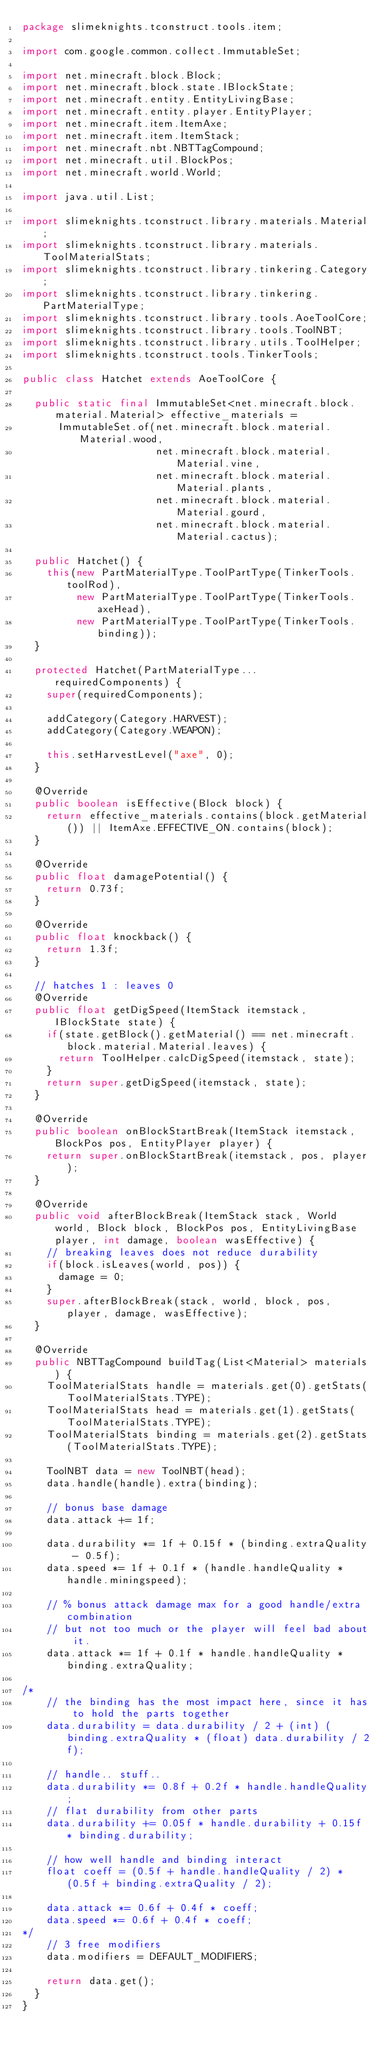<code> <loc_0><loc_0><loc_500><loc_500><_Java_>package slimeknights.tconstruct.tools.item;

import com.google.common.collect.ImmutableSet;

import net.minecraft.block.Block;
import net.minecraft.block.state.IBlockState;
import net.minecraft.entity.EntityLivingBase;
import net.minecraft.entity.player.EntityPlayer;
import net.minecraft.item.ItemAxe;
import net.minecraft.item.ItemStack;
import net.minecraft.nbt.NBTTagCompound;
import net.minecraft.util.BlockPos;
import net.minecraft.world.World;

import java.util.List;

import slimeknights.tconstruct.library.materials.Material;
import slimeknights.tconstruct.library.materials.ToolMaterialStats;
import slimeknights.tconstruct.library.tinkering.Category;
import slimeknights.tconstruct.library.tinkering.PartMaterialType;
import slimeknights.tconstruct.library.tools.AoeToolCore;
import slimeknights.tconstruct.library.tools.ToolNBT;
import slimeknights.tconstruct.library.utils.ToolHelper;
import slimeknights.tconstruct.tools.TinkerTools;

public class Hatchet extends AoeToolCore {

  public static final ImmutableSet<net.minecraft.block.material.Material> effective_materials =
      ImmutableSet.of(net.minecraft.block.material.Material.wood,
                      net.minecraft.block.material.Material.vine,
                      net.minecraft.block.material.Material.plants,
                      net.minecraft.block.material.Material.gourd,
                      net.minecraft.block.material.Material.cactus);

  public Hatchet() {
    this(new PartMaterialType.ToolPartType(TinkerTools.toolRod),
         new PartMaterialType.ToolPartType(TinkerTools.axeHead),
         new PartMaterialType.ToolPartType(TinkerTools.binding));
  }

  protected Hatchet(PartMaterialType... requiredComponents) {
    super(requiredComponents);

    addCategory(Category.HARVEST);
    addCategory(Category.WEAPON);

    this.setHarvestLevel("axe", 0);
  }

  @Override
  public boolean isEffective(Block block) {
    return effective_materials.contains(block.getMaterial()) || ItemAxe.EFFECTIVE_ON.contains(block);
  }

  @Override
  public float damagePotential() {
    return 0.73f;
  }

  @Override
  public float knockback() {
    return 1.3f;
  }

  // hatches 1 : leaves 0
  @Override
  public float getDigSpeed(ItemStack itemstack, IBlockState state) {
    if(state.getBlock().getMaterial() == net.minecraft.block.material.Material.leaves) {
      return ToolHelper.calcDigSpeed(itemstack, state);
    }
    return super.getDigSpeed(itemstack, state);
  }

  @Override
  public boolean onBlockStartBreak(ItemStack itemstack, BlockPos pos, EntityPlayer player) {
    return super.onBlockStartBreak(itemstack, pos, player);
  }

  @Override
  public void afterBlockBreak(ItemStack stack, World world, Block block, BlockPos pos, EntityLivingBase player, int damage, boolean wasEffective) {
    // breaking leaves does not reduce durability
    if(block.isLeaves(world, pos)) {
      damage = 0;
    }
    super.afterBlockBreak(stack, world, block, pos, player, damage, wasEffective);
  }

  @Override
  public NBTTagCompound buildTag(List<Material> materials) {
    ToolMaterialStats handle = materials.get(0).getStats(ToolMaterialStats.TYPE);
    ToolMaterialStats head = materials.get(1).getStats(ToolMaterialStats.TYPE);
    ToolMaterialStats binding = materials.get(2).getStats(ToolMaterialStats.TYPE);

    ToolNBT data = new ToolNBT(head);
    data.handle(handle).extra(binding);

    // bonus base damage
    data.attack += 1f;

    data.durability *= 1f + 0.15f * (binding.extraQuality - 0.5f);
    data.speed *= 1f + 0.1f * (handle.handleQuality * handle.miningspeed);

    // % bonus attack damage max for a good handle/extra combination
    // but not too much or the player will feel bad about it.
    data.attack *= 1f + 0.1f * handle.handleQuality * binding.extraQuality;

/*
    // the binding has the most impact here, since it has to hold the parts together
    data.durability = data.durability / 2 + (int) (binding.extraQuality * (float) data.durability / 2f);

    // handle.. stuff..
    data.durability *= 0.8f + 0.2f * handle.handleQuality;
    // flat durability from other parts
    data.durability += 0.05f * handle.durability + 0.15f * binding.durability;

    // how well handle and binding interact
    float coeff = (0.5f + handle.handleQuality / 2) * (0.5f + binding.extraQuality / 2);

    data.attack *= 0.6f + 0.4f * coeff;
    data.speed *= 0.6f + 0.4f * coeff;
*/
    // 3 free modifiers
    data.modifiers = DEFAULT_MODIFIERS;

    return data.get();
  }
}
</code> 